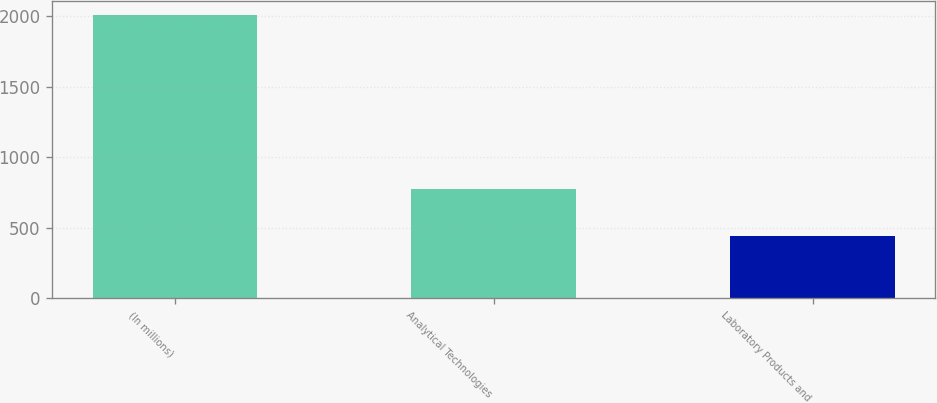Convert chart. <chart><loc_0><loc_0><loc_500><loc_500><bar_chart><fcel>(In millions)<fcel>Analytical Technologies<fcel>Laboratory Products and<nl><fcel>2008<fcel>777.3<fcel>438.9<nl></chart> 